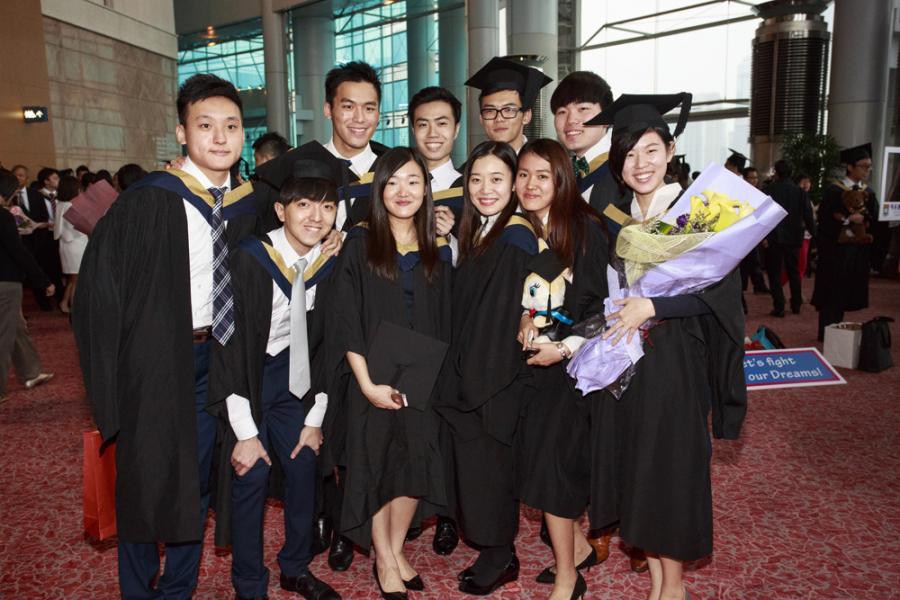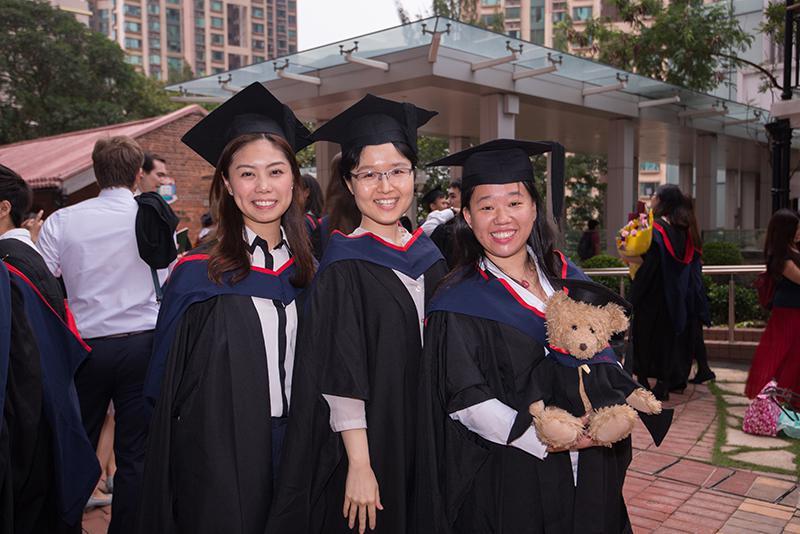The first image is the image on the left, the second image is the image on the right. Given the left and right images, does the statement "Two graduates pose for a picture in one of the images." hold true? Answer yes or no. No. 